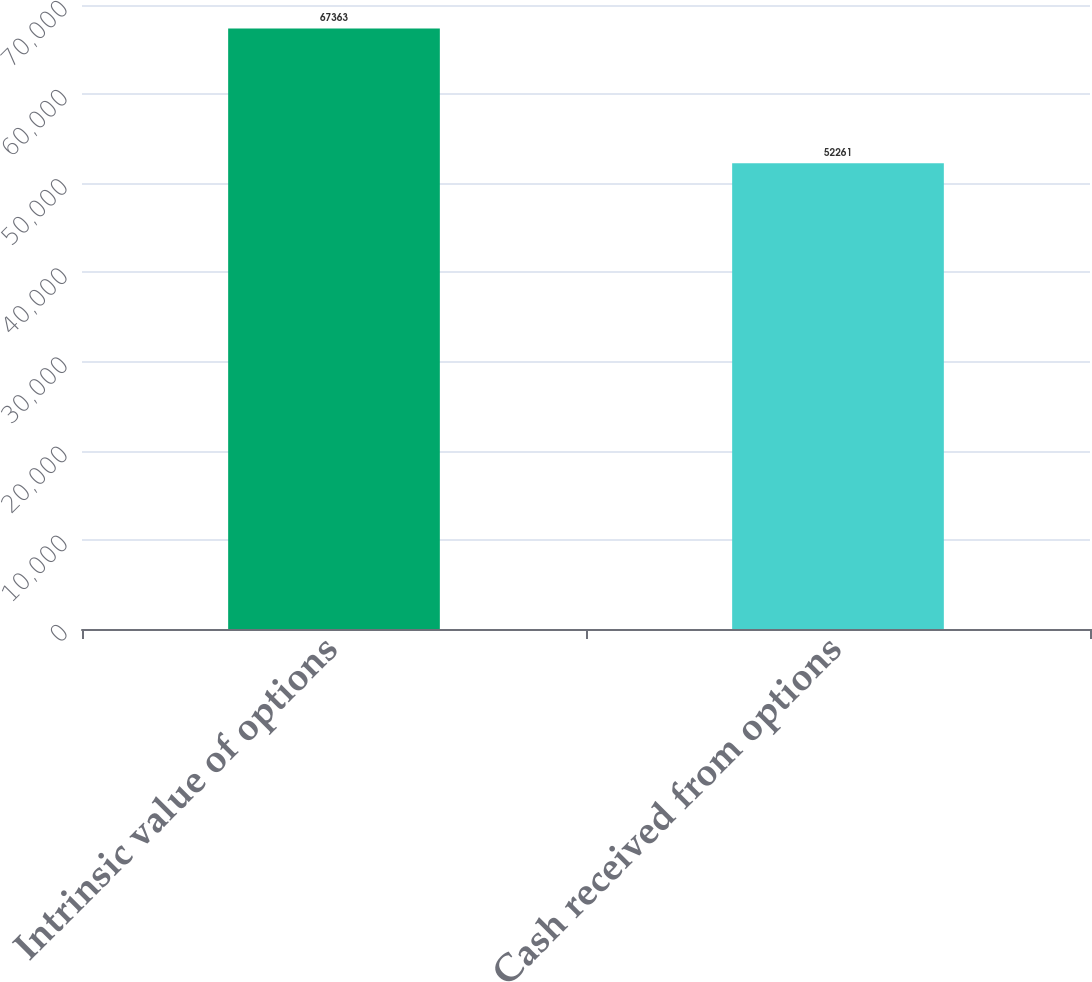Convert chart. <chart><loc_0><loc_0><loc_500><loc_500><bar_chart><fcel>Intrinsic value of options<fcel>Cash received from options<nl><fcel>67363<fcel>52261<nl></chart> 